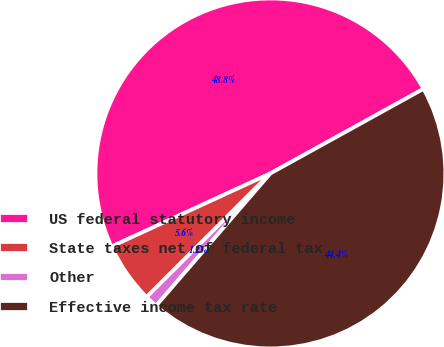Convert chart to OTSL. <chart><loc_0><loc_0><loc_500><loc_500><pie_chart><fcel>US federal statutory income<fcel>State taxes net of federal tax<fcel>Other<fcel>Effective income tax rate<nl><fcel>48.83%<fcel>5.63%<fcel>1.17%<fcel>44.37%<nl></chart> 